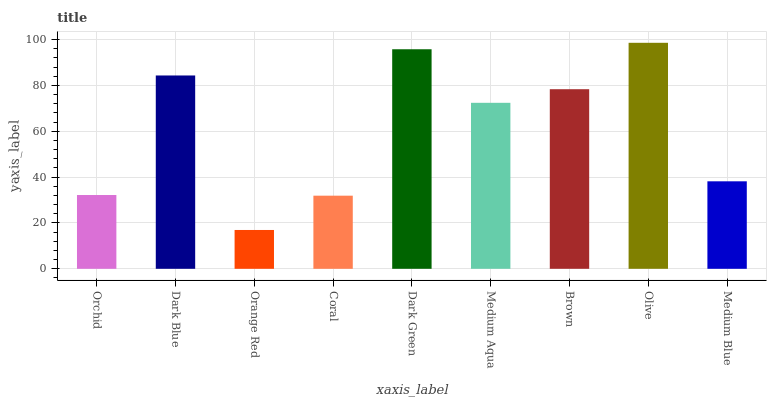Is Dark Blue the minimum?
Answer yes or no. No. Is Dark Blue the maximum?
Answer yes or no. No. Is Dark Blue greater than Orchid?
Answer yes or no. Yes. Is Orchid less than Dark Blue?
Answer yes or no. Yes. Is Orchid greater than Dark Blue?
Answer yes or no. No. Is Dark Blue less than Orchid?
Answer yes or no. No. Is Medium Aqua the high median?
Answer yes or no. Yes. Is Medium Aqua the low median?
Answer yes or no. Yes. Is Coral the high median?
Answer yes or no. No. Is Brown the low median?
Answer yes or no. No. 